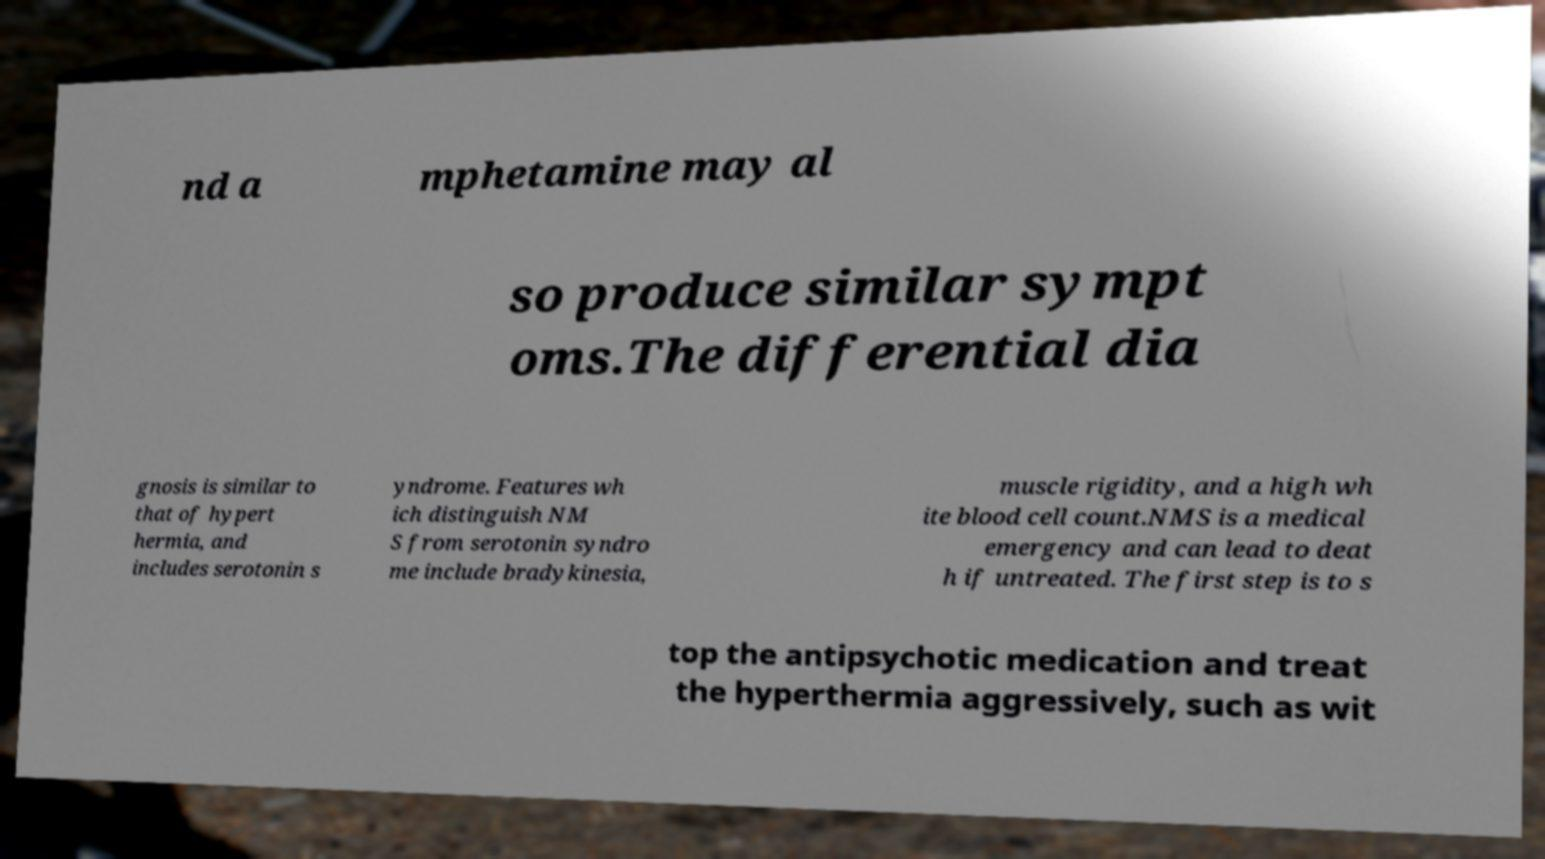Please identify and transcribe the text found in this image. nd a mphetamine may al so produce similar sympt oms.The differential dia gnosis is similar to that of hypert hermia, and includes serotonin s yndrome. Features wh ich distinguish NM S from serotonin syndro me include bradykinesia, muscle rigidity, and a high wh ite blood cell count.NMS is a medical emergency and can lead to deat h if untreated. The first step is to s top the antipsychotic medication and treat the hyperthermia aggressively, such as wit 